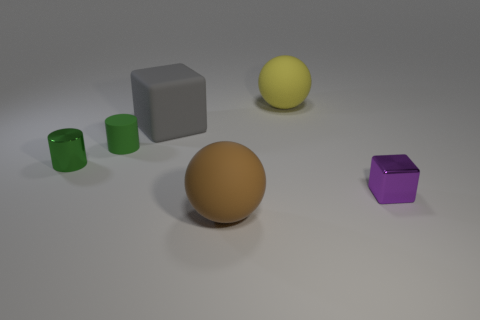Add 4 tiny purple cylinders. How many objects exist? 10 Subtract all blocks. How many objects are left? 4 Subtract 1 spheres. How many spheres are left? 1 Subtract all purple blocks. How many blocks are left? 1 Subtract all purple blocks. Subtract all purple spheres. How many blocks are left? 1 Subtract all brown cylinders. How many yellow spheres are left? 1 Subtract all big gray blocks. Subtract all large objects. How many objects are left? 2 Add 2 large yellow balls. How many large yellow balls are left? 3 Add 1 shiny blocks. How many shiny blocks exist? 2 Subtract 0 blue cylinders. How many objects are left? 6 